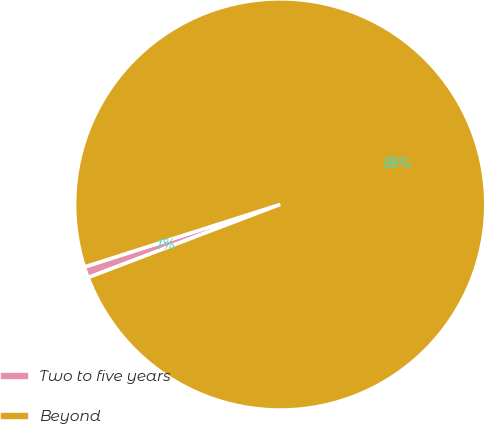Convert chart. <chart><loc_0><loc_0><loc_500><loc_500><pie_chart><fcel>Two to five years<fcel>Beyond<nl><fcel>0.87%<fcel>99.13%<nl></chart> 